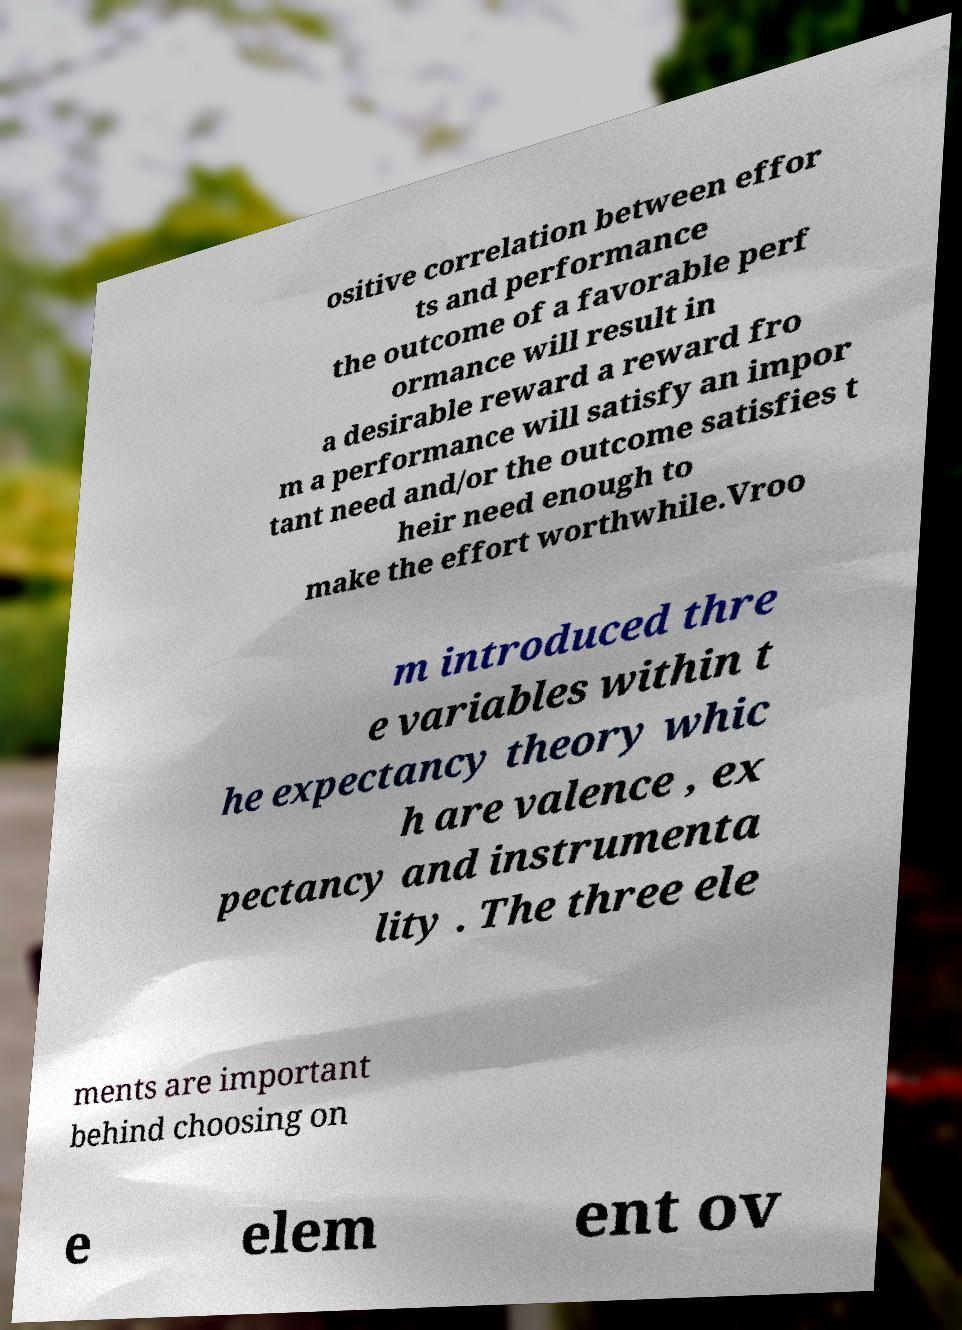I need the written content from this picture converted into text. Can you do that? ositive correlation between effor ts and performance the outcome of a favorable perf ormance will result in a desirable reward a reward fro m a performance will satisfy an impor tant need and/or the outcome satisfies t heir need enough to make the effort worthwhile.Vroo m introduced thre e variables within t he expectancy theory whic h are valence , ex pectancy and instrumenta lity . The three ele ments are important behind choosing on e elem ent ov 